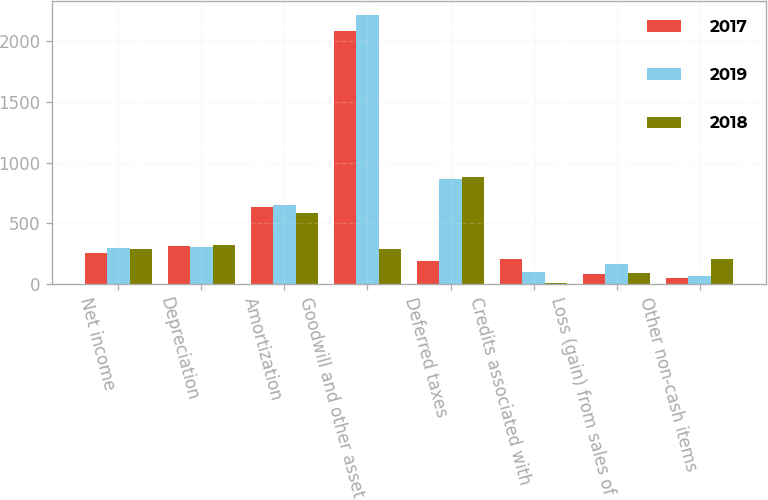<chart> <loc_0><loc_0><loc_500><loc_500><stacked_bar_chart><ecel><fcel>Net income<fcel>Depreciation<fcel>Amortization<fcel>Goodwill and other asset<fcel>Deferred taxes<fcel>Credits associated with<fcel>Loss (gain) from sales of<fcel>Other non-cash items<nl><fcel>2017<fcel>255<fcel>317<fcel>632<fcel>2079<fcel>189<fcel>210<fcel>86<fcel>52<nl><fcel>2019<fcel>297<fcel>303<fcel>648<fcel>2217<fcel>868<fcel>99<fcel>169<fcel>67<nl><fcel>2018<fcel>290<fcel>324<fcel>586<fcel>290<fcel>882<fcel>7<fcel>94<fcel>203<nl></chart> 